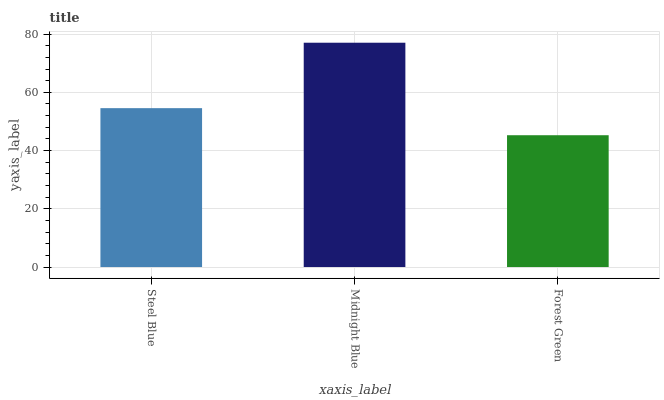Is Forest Green the minimum?
Answer yes or no. Yes. Is Midnight Blue the maximum?
Answer yes or no. Yes. Is Midnight Blue the minimum?
Answer yes or no. No. Is Forest Green the maximum?
Answer yes or no. No. Is Midnight Blue greater than Forest Green?
Answer yes or no. Yes. Is Forest Green less than Midnight Blue?
Answer yes or no. Yes. Is Forest Green greater than Midnight Blue?
Answer yes or no. No. Is Midnight Blue less than Forest Green?
Answer yes or no. No. Is Steel Blue the high median?
Answer yes or no. Yes. Is Steel Blue the low median?
Answer yes or no. Yes. Is Forest Green the high median?
Answer yes or no. No. Is Midnight Blue the low median?
Answer yes or no. No. 